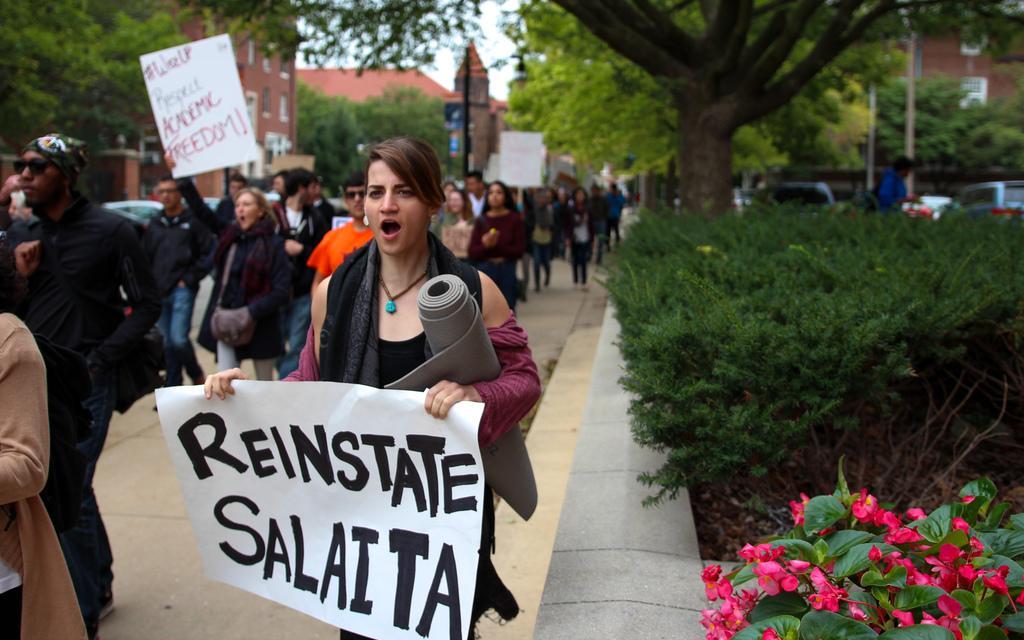How would you summarize this image in a sentence or two? In this picture there are group of people walking on the footpath and there are three persons holding the placards and there is text on the placards and there are vehicles on the road and there are buildings, trees and poles. In the foreground there are flowers. At the top there is sky. At the bottom there is a road. 